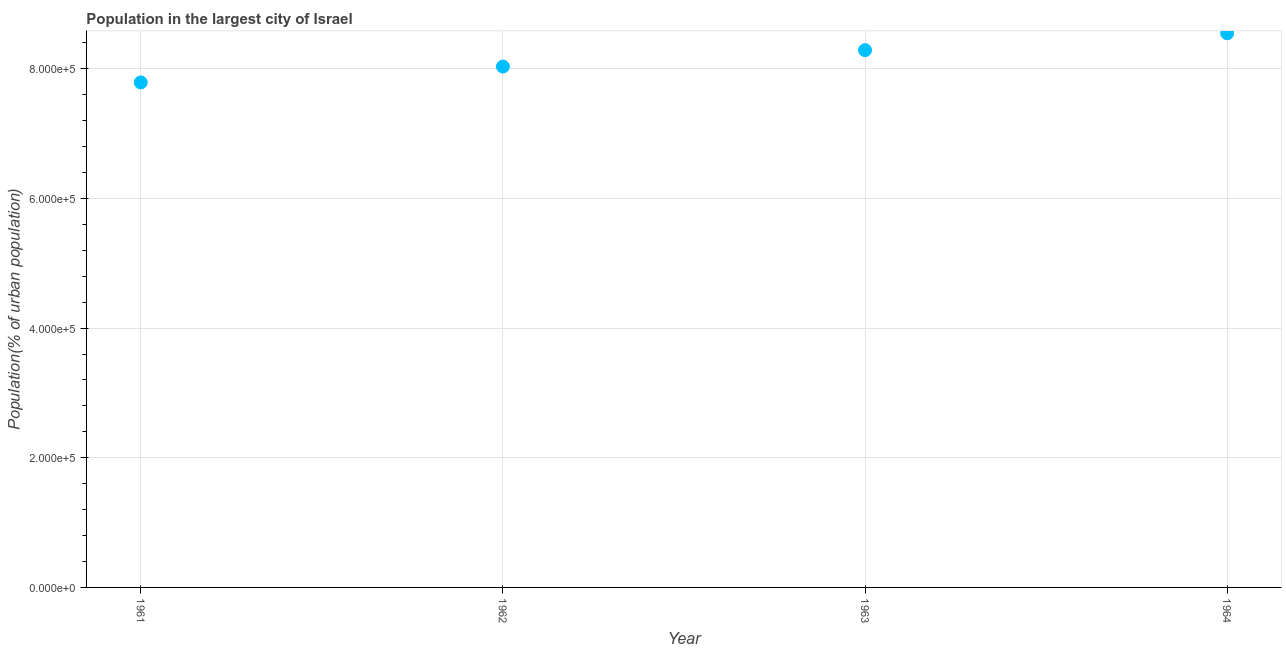What is the population in largest city in 1962?
Your answer should be very brief. 8.04e+05. Across all years, what is the maximum population in largest city?
Offer a very short reply. 8.55e+05. Across all years, what is the minimum population in largest city?
Your answer should be compact. 7.79e+05. In which year was the population in largest city maximum?
Provide a succinct answer. 1964. In which year was the population in largest city minimum?
Ensure brevity in your answer.  1961. What is the sum of the population in largest city?
Provide a short and direct response. 3.27e+06. What is the difference between the population in largest city in 1961 and 1964?
Provide a succinct answer. -7.58e+04. What is the average population in largest city per year?
Your response must be concise. 8.17e+05. What is the median population in largest city?
Provide a succinct answer. 8.16e+05. In how many years, is the population in largest city greater than 120000 %?
Make the answer very short. 4. Do a majority of the years between 1964 and 1962 (inclusive) have population in largest city greater than 360000 %?
Make the answer very short. No. What is the ratio of the population in largest city in 1961 to that in 1964?
Your answer should be compact. 0.91. What is the difference between the highest and the second highest population in largest city?
Your answer should be very brief. 2.61e+04. What is the difference between the highest and the lowest population in largest city?
Your answer should be very brief. 7.58e+04. How many dotlines are there?
Your answer should be very brief. 1. How many years are there in the graph?
Make the answer very short. 4. Does the graph contain any zero values?
Offer a very short reply. No. Does the graph contain grids?
Your response must be concise. Yes. What is the title of the graph?
Offer a terse response. Population in the largest city of Israel. What is the label or title of the Y-axis?
Make the answer very short. Population(% of urban population). What is the Population(% of urban population) in 1961?
Your answer should be compact. 7.79e+05. What is the Population(% of urban population) in 1962?
Ensure brevity in your answer.  8.04e+05. What is the Population(% of urban population) in 1963?
Ensure brevity in your answer.  8.29e+05. What is the Population(% of urban population) in 1964?
Ensure brevity in your answer.  8.55e+05. What is the difference between the Population(% of urban population) in 1961 and 1962?
Your answer should be compact. -2.45e+04. What is the difference between the Population(% of urban population) in 1961 and 1963?
Your answer should be compact. -4.97e+04. What is the difference between the Population(% of urban population) in 1961 and 1964?
Give a very brief answer. -7.58e+04. What is the difference between the Population(% of urban population) in 1962 and 1963?
Your response must be concise. -2.52e+04. What is the difference between the Population(% of urban population) in 1962 and 1964?
Keep it short and to the point. -5.13e+04. What is the difference between the Population(% of urban population) in 1963 and 1964?
Provide a short and direct response. -2.61e+04. What is the ratio of the Population(% of urban population) in 1961 to that in 1962?
Provide a succinct answer. 0.97. What is the ratio of the Population(% of urban population) in 1961 to that in 1963?
Make the answer very short. 0.94. What is the ratio of the Population(% of urban population) in 1961 to that in 1964?
Provide a short and direct response. 0.91. What is the ratio of the Population(% of urban population) in 1962 to that in 1963?
Provide a short and direct response. 0.97. 